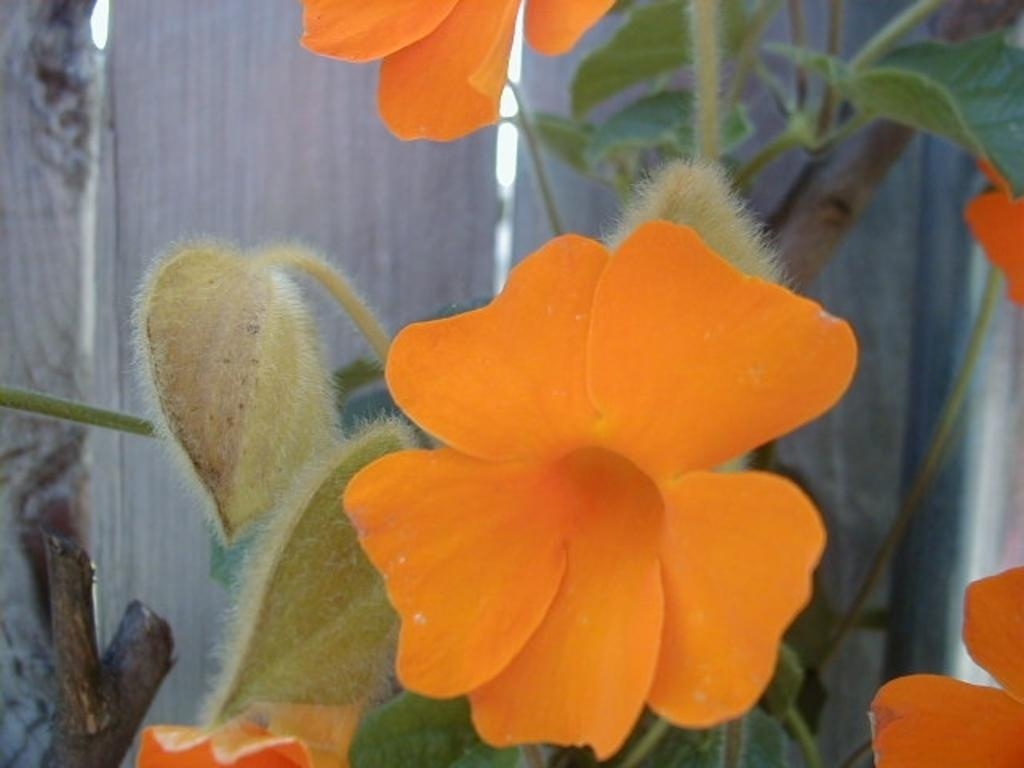What type of living organisms can be seen in the image? There are flowers and a plant visible in the image. What material is the wall in the background made of? The wall in the background of the image is made of wood. What type of gold spark can be seen on the yam in the image? There is no gold spark or yam present in the image; it features flowers and a plant with a wooden wall in the background. 